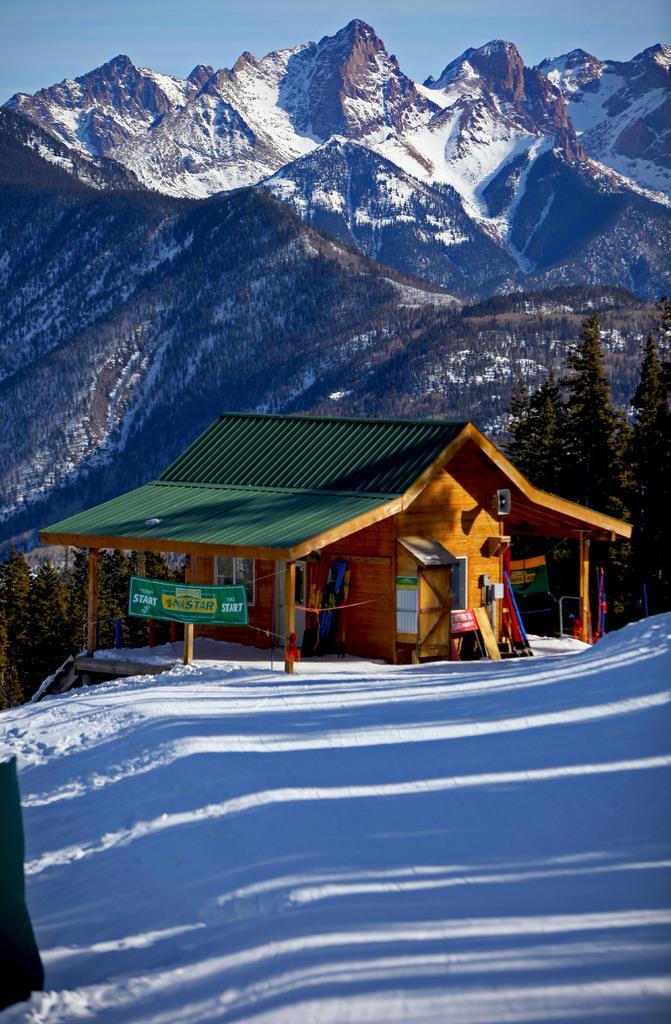Please provide a concise description of this image. In this image we can see a house, banners, boards, snow, trees, and few objects. In the background we can see mountains and sky. 